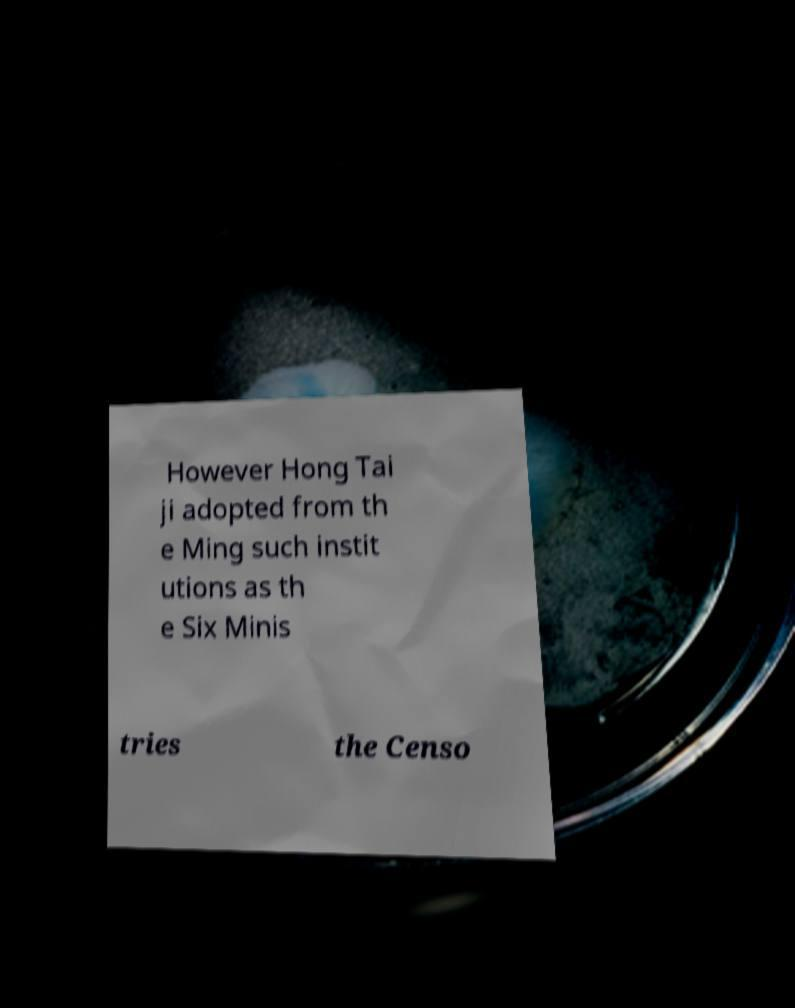For documentation purposes, I need the text within this image transcribed. Could you provide that? However Hong Tai ji adopted from th e Ming such instit utions as th e Six Minis tries the Censo 